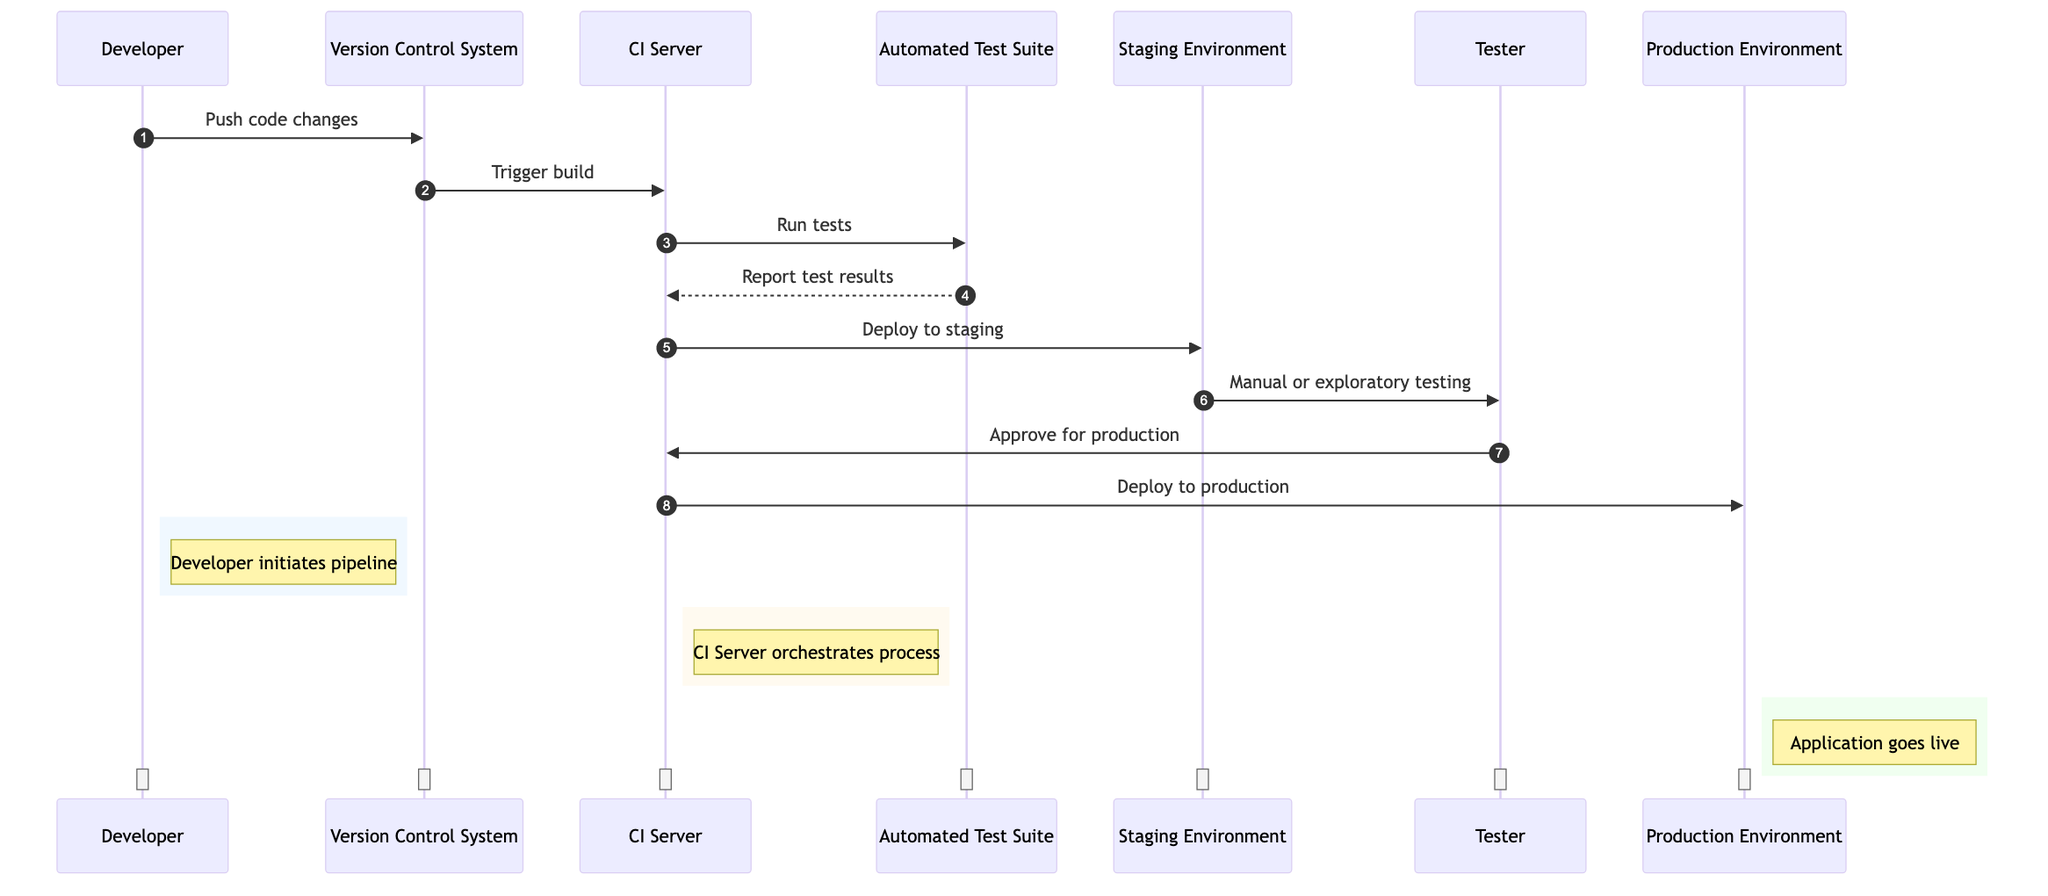What starts the CI/CD pipeline? The CI/CD pipeline is initiated by the Developer who pushes code changes to the Version Control System.
Answer: Developer How many environments are shown in the diagram? The diagram indicates two environments: Staging Environment and Production Environment.
Answer: Two Who sends the report of the test results? The Automated Test Suite sends the report of the test results back to the CI Server.
Answer: Automated Test Suite What action does the CI Server perform after receiving test results? After receiving the test results, the CI Server deploys the code to the Staging Environment.
Answer: Deploy to staging What is the last action performed in the sequence? The last action performed in the sequence is the CI Server deploying to the Production Environment.
Answer: Deploy to production Which actor approves the deployment to production? The Tester is responsible for approving the deployment to production.
Answer: Tester What is the role of the CI Server in the pipeline? The CI Server orchestrates the process by running builds, tests, and deployments.
Answer: Orchestrates process What type of testing occurs in the Staging Environment? Manual or exploratory testing takes place in the Staging Environment.
Answer: Manual or exploratory testing How does the Version Control System contribute to the CI/CD pipeline? The Version Control System stores the codebase and triggers the build process when code changes are pushed.
Answer: Trigger build What is the purpose of the Staging Environment? The Staging Environment simulates production for testing purposes.
Answer: Testing Environment 